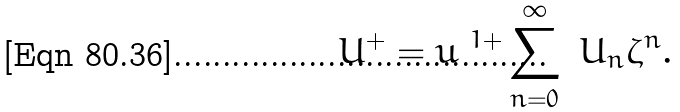Convert formula to latex. <formula><loc_0><loc_0><loc_500><loc_500>\ U ^ { + } = u ^ { \ 1 + } \sum _ { n = 0 } ^ { \infty } \ U _ { n } \zeta ^ { n } .</formula> 